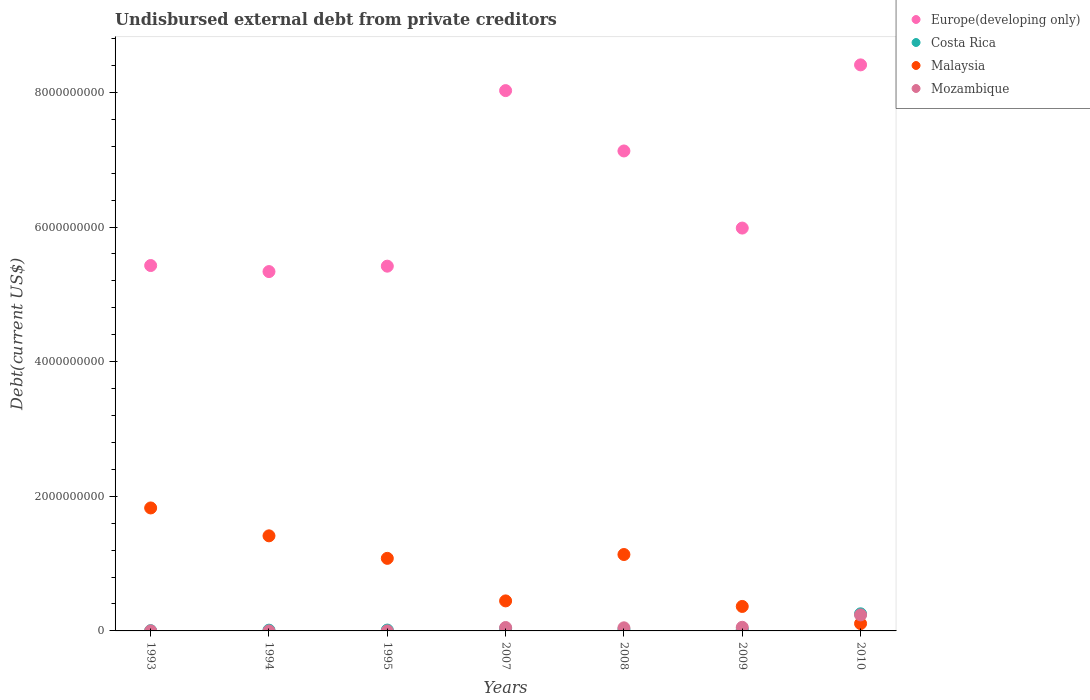How many different coloured dotlines are there?
Give a very brief answer. 4. What is the total debt in Malaysia in 1995?
Your answer should be compact. 1.08e+09. Across all years, what is the maximum total debt in Costa Rica?
Provide a short and direct response. 2.54e+08. Across all years, what is the minimum total debt in Mozambique?
Your answer should be very brief. 2.40e+04. In which year was the total debt in Costa Rica minimum?
Offer a very short reply. 1993. What is the total total debt in Costa Rica in the graph?
Your answer should be compact. 3.65e+08. What is the difference between the total debt in Costa Rica in 2007 and that in 2009?
Give a very brief answer. 1.15e+07. What is the difference between the total debt in Costa Rica in 1993 and the total debt in Malaysia in 1994?
Offer a terse response. -1.41e+09. What is the average total debt in Europe(developing only) per year?
Offer a terse response. 6.53e+09. In the year 2009, what is the difference between the total debt in Europe(developing only) and total debt in Mozambique?
Provide a succinct answer. 5.93e+09. What is the ratio of the total debt in Malaysia in 1995 to that in 2010?
Your answer should be very brief. 9.88. Is the difference between the total debt in Europe(developing only) in 2009 and 2010 greater than the difference between the total debt in Mozambique in 2009 and 2010?
Offer a very short reply. No. What is the difference between the highest and the second highest total debt in Malaysia?
Provide a succinct answer. 4.14e+08. What is the difference between the highest and the lowest total debt in Malaysia?
Ensure brevity in your answer.  1.72e+09. In how many years, is the total debt in Costa Rica greater than the average total debt in Costa Rica taken over all years?
Your answer should be very brief. 1. Is it the case that in every year, the sum of the total debt in Europe(developing only) and total debt in Costa Rica  is greater than the sum of total debt in Malaysia and total debt in Mozambique?
Make the answer very short. Yes. Is it the case that in every year, the sum of the total debt in Europe(developing only) and total debt in Malaysia  is greater than the total debt in Costa Rica?
Offer a terse response. Yes. Is the total debt in Mozambique strictly greater than the total debt in Europe(developing only) over the years?
Make the answer very short. No. How many years are there in the graph?
Provide a short and direct response. 7. What is the difference between two consecutive major ticks on the Y-axis?
Your answer should be compact. 2.00e+09. Are the values on the major ticks of Y-axis written in scientific E-notation?
Provide a succinct answer. No. Does the graph contain grids?
Keep it short and to the point. No. How many legend labels are there?
Offer a terse response. 4. What is the title of the graph?
Provide a succinct answer. Undisbursed external debt from private creditors. Does "Sudan" appear as one of the legend labels in the graph?
Offer a very short reply. No. What is the label or title of the Y-axis?
Make the answer very short. Debt(current US$). What is the Debt(current US$) in Europe(developing only) in 1993?
Provide a succinct answer. 5.43e+09. What is the Debt(current US$) of Costa Rica in 1993?
Offer a very short reply. 3.76e+06. What is the Debt(current US$) in Malaysia in 1993?
Make the answer very short. 1.83e+09. What is the Debt(current US$) of Mozambique in 1993?
Provide a succinct answer. 6.41e+05. What is the Debt(current US$) in Europe(developing only) in 1994?
Provide a short and direct response. 5.34e+09. What is the Debt(current US$) of Costa Rica in 1994?
Offer a terse response. 1.12e+07. What is the Debt(current US$) in Malaysia in 1994?
Offer a very short reply. 1.41e+09. What is the Debt(current US$) of Mozambique in 1994?
Make the answer very short. 2.40e+04. What is the Debt(current US$) of Europe(developing only) in 1995?
Your answer should be very brief. 5.42e+09. What is the Debt(current US$) in Costa Rica in 1995?
Offer a terse response. 1.28e+07. What is the Debt(current US$) in Malaysia in 1995?
Keep it short and to the point. 1.08e+09. What is the Debt(current US$) of Mozambique in 1995?
Keep it short and to the point. 2.70e+04. What is the Debt(current US$) of Europe(developing only) in 2007?
Your answer should be compact. 8.03e+09. What is the Debt(current US$) of Costa Rica in 2007?
Make the answer very short. 3.57e+07. What is the Debt(current US$) of Malaysia in 2007?
Your answer should be compact. 4.46e+08. What is the Debt(current US$) in Mozambique in 2007?
Provide a short and direct response. 5.06e+07. What is the Debt(current US$) of Europe(developing only) in 2008?
Offer a terse response. 7.13e+09. What is the Debt(current US$) of Costa Rica in 2008?
Ensure brevity in your answer.  2.34e+07. What is the Debt(current US$) in Malaysia in 2008?
Provide a succinct answer. 1.14e+09. What is the Debt(current US$) of Mozambique in 2008?
Provide a short and direct response. 4.61e+07. What is the Debt(current US$) in Europe(developing only) in 2009?
Your response must be concise. 5.98e+09. What is the Debt(current US$) of Costa Rica in 2009?
Ensure brevity in your answer.  2.42e+07. What is the Debt(current US$) of Malaysia in 2009?
Keep it short and to the point. 3.64e+08. What is the Debt(current US$) of Mozambique in 2009?
Provide a succinct answer. 5.40e+07. What is the Debt(current US$) in Europe(developing only) in 2010?
Give a very brief answer. 8.41e+09. What is the Debt(current US$) in Costa Rica in 2010?
Provide a succinct answer. 2.54e+08. What is the Debt(current US$) of Malaysia in 2010?
Offer a very short reply. 1.09e+08. What is the Debt(current US$) of Mozambique in 2010?
Keep it short and to the point. 2.38e+08. Across all years, what is the maximum Debt(current US$) in Europe(developing only)?
Keep it short and to the point. 8.41e+09. Across all years, what is the maximum Debt(current US$) of Costa Rica?
Give a very brief answer. 2.54e+08. Across all years, what is the maximum Debt(current US$) of Malaysia?
Give a very brief answer. 1.83e+09. Across all years, what is the maximum Debt(current US$) of Mozambique?
Give a very brief answer. 2.38e+08. Across all years, what is the minimum Debt(current US$) in Europe(developing only)?
Ensure brevity in your answer.  5.34e+09. Across all years, what is the minimum Debt(current US$) in Costa Rica?
Offer a very short reply. 3.76e+06. Across all years, what is the minimum Debt(current US$) of Malaysia?
Offer a very short reply. 1.09e+08. Across all years, what is the minimum Debt(current US$) of Mozambique?
Your answer should be compact. 2.40e+04. What is the total Debt(current US$) in Europe(developing only) in the graph?
Give a very brief answer. 4.57e+1. What is the total Debt(current US$) of Costa Rica in the graph?
Offer a terse response. 3.65e+08. What is the total Debt(current US$) in Malaysia in the graph?
Your answer should be compact. 6.37e+09. What is the total Debt(current US$) of Mozambique in the graph?
Ensure brevity in your answer.  3.89e+08. What is the difference between the Debt(current US$) of Europe(developing only) in 1993 and that in 1994?
Provide a short and direct response. 8.98e+07. What is the difference between the Debt(current US$) in Costa Rica in 1993 and that in 1994?
Give a very brief answer. -7.47e+06. What is the difference between the Debt(current US$) of Malaysia in 1993 and that in 1994?
Keep it short and to the point. 4.14e+08. What is the difference between the Debt(current US$) of Mozambique in 1993 and that in 1994?
Keep it short and to the point. 6.17e+05. What is the difference between the Debt(current US$) of Europe(developing only) in 1993 and that in 1995?
Make the answer very short. 9.35e+06. What is the difference between the Debt(current US$) in Costa Rica in 1993 and that in 1995?
Offer a terse response. -9.03e+06. What is the difference between the Debt(current US$) of Malaysia in 1993 and that in 1995?
Your answer should be very brief. 7.49e+08. What is the difference between the Debt(current US$) of Mozambique in 1993 and that in 1995?
Ensure brevity in your answer.  6.14e+05. What is the difference between the Debt(current US$) in Europe(developing only) in 1993 and that in 2007?
Offer a terse response. -2.60e+09. What is the difference between the Debt(current US$) of Costa Rica in 1993 and that in 2007?
Give a very brief answer. -3.20e+07. What is the difference between the Debt(current US$) in Malaysia in 1993 and that in 2007?
Ensure brevity in your answer.  1.38e+09. What is the difference between the Debt(current US$) in Mozambique in 1993 and that in 2007?
Your answer should be compact. -5.00e+07. What is the difference between the Debt(current US$) of Europe(developing only) in 1993 and that in 2008?
Offer a terse response. -1.70e+09. What is the difference between the Debt(current US$) in Costa Rica in 1993 and that in 2008?
Provide a short and direct response. -1.96e+07. What is the difference between the Debt(current US$) of Malaysia in 1993 and that in 2008?
Keep it short and to the point. 6.92e+08. What is the difference between the Debt(current US$) of Mozambique in 1993 and that in 2008?
Keep it short and to the point. -4.55e+07. What is the difference between the Debt(current US$) in Europe(developing only) in 1993 and that in 2009?
Offer a very short reply. -5.57e+08. What is the difference between the Debt(current US$) in Costa Rica in 1993 and that in 2009?
Your answer should be very brief. -2.04e+07. What is the difference between the Debt(current US$) of Malaysia in 1993 and that in 2009?
Your answer should be very brief. 1.46e+09. What is the difference between the Debt(current US$) in Mozambique in 1993 and that in 2009?
Your response must be concise. -5.33e+07. What is the difference between the Debt(current US$) in Europe(developing only) in 1993 and that in 2010?
Ensure brevity in your answer.  -2.98e+09. What is the difference between the Debt(current US$) in Costa Rica in 1993 and that in 2010?
Keep it short and to the point. -2.50e+08. What is the difference between the Debt(current US$) of Malaysia in 1993 and that in 2010?
Provide a short and direct response. 1.72e+09. What is the difference between the Debt(current US$) of Mozambique in 1993 and that in 2010?
Give a very brief answer. -2.37e+08. What is the difference between the Debt(current US$) of Europe(developing only) in 1994 and that in 1995?
Provide a short and direct response. -8.05e+07. What is the difference between the Debt(current US$) of Costa Rica in 1994 and that in 1995?
Keep it short and to the point. -1.56e+06. What is the difference between the Debt(current US$) of Malaysia in 1994 and that in 1995?
Provide a short and direct response. 3.34e+08. What is the difference between the Debt(current US$) of Mozambique in 1994 and that in 1995?
Offer a very short reply. -3000. What is the difference between the Debt(current US$) in Europe(developing only) in 1994 and that in 2007?
Offer a very short reply. -2.69e+09. What is the difference between the Debt(current US$) in Costa Rica in 1994 and that in 2007?
Your answer should be compact. -2.45e+07. What is the difference between the Debt(current US$) in Malaysia in 1994 and that in 2007?
Give a very brief answer. 9.67e+08. What is the difference between the Debt(current US$) of Mozambique in 1994 and that in 2007?
Provide a succinct answer. -5.06e+07. What is the difference between the Debt(current US$) of Europe(developing only) in 1994 and that in 2008?
Give a very brief answer. -1.79e+09. What is the difference between the Debt(current US$) of Costa Rica in 1994 and that in 2008?
Keep it short and to the point. -1.21e+07. What is the difference between the Debt(current US$) of Malaysia in 1994 and that in 2008?
Your answer should be compact. 2.77e+08. What is the difference between the Debt(current US$) of Mozambique in 1994 and that in 2008?
Provide a short and direct response. -4.61e+07. What is the difference between the Debt(current US$) of Europe(developing only) in 1994 and that in 2009?
Your response must be concise. -6.46e+08. What is the difference between the Debt(current US$) of Costa Rica in 1994 and that in 2009?
Provide a short and direct response. -1.30e+07. What is the difference between the Debt(current US$) of Malaysia in 1994 and that in 2009?
Provide a succinct answer. 1.05e+09. What is the difference between the Debt(current US$) of Mozambique in 1994 and that in 2009?
Give a very brief answer. -5.39e+07. What is the difference between the Debt(current US$) in Europe(developing only) in 1994 and that in 2010?
Keep it short and to the point. -3.07e+09. What is the difference between the Debt(current US$) in Costa Rica in 1994 and that in 2010?
Keep it short and to the point. -2.43e+08. What is the difference between the Debt(current US$) of Malaysia in 1994 and that in 2010?
Your answer should be compact. 1.30e+09. What is the difference between the Debt(current US$) of Mozambique in 1994 and that in 2010?
Provide a succinct answer. -2.38e+08. What is the difference between the Debt(current US$) of Europe(developing only) in 1995 and that in 2007?
Your response must be concise. -2.61e+09. What is the difference between the Debt(current US$) in Costa Rica in 1995 and that in 2007?
Make the answer very short. -2.29e+07. What is the difference between the Debt(current US$) in Malaysia in 1995 and that in 2007?
Your answer should be compact. 6.32e+08. What is the difference between the Debt(current US$) in Mozambique in 1995 and that in 2007?
Provide a short and direct response. -5.06e+07. What is the difference between the Debt(current US$) in Europe(developing only) in 1995 and that in 2008?
Keep it short and to the point. -1.71e+09. What is the difference between the Debt(current US$) of Costa Rica in 1995 and that in 2008?
Give a very brief answer. -1.06e+07. What is the difference between the Debt(current US$) in Malaysia in 1995 and that in 2008?
Ensure brevity in your answer.  -5.69e+07. What is the difference between the Debt(current US$) of Mozambique in 1995 and that in 2008?
Provide a short and direct response. -4.61e+07. What is the difference between the Debt(current US$) of Europe(developing only) in 1995 and that in 2009?
Give a very brief answer. -5.66e+08. What is the difference between the Debt(current US$) of Costa Rica in 1995 and that in 2009?
Your answer should be very brief. -1.14e+07. What is the difference between the Debt(current US$) of Malaysia in 1995 and that in 2009?
Provide a succinct answer. 7.14e+08. What is the difference between the Debt(current US$) in Mozambique in 1995 and that in 2009?
Provide a short and direct response. -5.39e+07. What is the difference between the Debt(current US$) of Europe(developing only) in 1995 and that in 2010?
Keep it short and to the point. -2.99e+09. What is the difference between the Debt(current US$) in Costa Rica in 1995 and that in 2010?
Your response must be concise. -2.41e+08. What is the difference between the Debt(current US$) in Malaysia in 1995 and that in 2010?
Offer a very short reply. 9.69e+08. What is the difference between the Debt(current US$) in Mozambique in 1995 and that in 2010?
Your answer should be very brief. -2.38e+08. What is the difference between the Debt(current US$) of Europe(developing only) in 2007 and that in 2008?
Your answer should be very brief. 8.97e+08. What is the difference between the Debt(current US$) of Costa Rica in 2007 and that in 2008?
Offer a terse response. 1.24e+07. What is the difference between the Debt(current US$) of Malaysia in 2007 and that in 2008?
Keep it short and to the point. -6.89e+08. What is the difference between the Debt(current US$) in Mozambique in 2007 and that in 2008?
Provide a short and direct response. 4.54e+06. What is the difference between the Debt(current US$) of Europe(developing only) in 2007 and that in 2009?
Your response must be concise. 2.04e+09. What is the difference between the Debt(current US$) in Costa Rica in 2007 and that in 2009?
Your response must be concise. 1.15e+07. What is the difference between the Debt(current US$) of Malaysia in 2007 and that in 2009?
Offer a very short reply. 8.24e+07. What is the difference between the Debt(current US$) in Mozambique in 2007 and that in 2009?
Your answer should be very brief. -3.32e+06. What is the difference between the Debt(current US$) of Europe(developing only) in 2007 and that in 2010?
Provide a short and direct response. -3.82e+08. What is the difference between the Debt(current US$) in Costa Rica in 2007 and that in 2010?
Give a very brief answer. -2.18e+08. What is the difference between the Debt(current US$) of Malaysia in 2007 and that in 2010?
Your response must be concise. 3.37e+08. What is the difference between the Debt(current US$) in Mozambique in 2007 and that in 2010?
Keep it short and to the point. -1.87e+08. What is the difference between the Debt(current US$) of Europe(developing only) in 2008 and that in 2009?
Your response must be concise. 1.15e+09. What is the difference between the Debt(current US$) in Costa Rica in 2008 and that in 2009?
Offer a very short reply. -8.21e+05. What is the difference between the Debt(current US$) in Malaysia in 2008 and that in 2009?
Your response must be concise. 7.71e+08. What is the difference between the Debt(current US$) in Mozambique in 2008 and that in 2009?
Provide a short and direct response. -7.85e+06. What is the difference between the Debt(current US$) of Europe(developing only) in 2008 and that in 2010?
Provide a short and direct response. -1.28e+09. What is the difference between the Debt(current US$) in Costa Rica in 2008 and that in 2010?
Your answer should be compact. -2.31e+08. What is the difference between the Debt(current US$) in Malaysia in 2008 and that in 2010?
Keep it short and to the point. 1.03e+09. What is the difference between the Debt(current US$) in Mozambique in 2008 and that in 2010?
Offer a very short reply. -1.92e+08. What is the difference between the Debt(current US$) of Europe(developing only) in 2009 and that in 2010?
Offer a very short reply. -2.42e+09. What is the difference between the Debt(current US$) in Costa Rica in 2009 and that in 2010?
Ensure brevity in your answer.  -2.30e+08. What is the difference between the Debt(current US$) in Malaysia in 2009 and that in 2010?
Make the answer very short. 2.55e+08. What is the difference between the Debt(current US$) of Mozambique in 2009 and that in 2010?
Keep it short and to the point. -1.84e+08. What is the difference between the Debt(current US$) of Europe(developing only) in 1993 and the Debt(current US$) of Costa Rica in 1994?
Your answer should be very brief. 5.42e+09. What is the difference between the Debt(current US$) in Europe(developing only) in 1993 and the Debt(current US$) in Malaysia in 1994?
Your answer should be compact. 4.02e+09. What is the difference between the Debt(current US$) of Europe(developing only) in 1993 and the Debt(current US$) of Mozambique in 1994?
Make the answer very short. 5.43e+09. What is the difference between the Debt(current US$) in Costa Rica in 1993 and the Debt(current US$) in Malaysia in 1994?
Offer a very short reply. -1.41e+09. What is the difference between the Debt(current US$) in Costa Rica in 1993 and the Debt(current US$) in Mozambique in 1994?
Make the answer very short. 3.74e+06. What is the difference between the Debt(current US$) in Malaysia in 1993 and the Debt(current US$) in Mozambique in 1994?
Ensure brevity in your answer.  1.83e+09. What is the difference between the Debt(current US$) of Europe(developing only) in 1993 and the Debt(current US$) of Costa Rica in 1995?
Your answer should be compact. 5.42e+09. What is the difference between the Debt(current US$) of Europe(developing only) in 1993 and the Debt(current US$) of Malaysia in 1995?
Your response must be concise. 4.35e+09. What is the difference between the Debt(current US$) of Europe(developing only) in 1993 and the Debt(current US$) of Mozambique in 1995?
Your answer should be very brief. 5.43e+09. What is the difference between the Debt(current US$) of Costa Rica in 1993 and the Debt(current US$) of Malaysia in 1995?
Ensure brevity in your answer.  -1.07e+09. What is the difference between the Debt(current US$) in Costa Rica in 1993 and the Debt(current US$) in Mozambique in 1995?
Your response must be concise. 3.73e+06. What is the difference between the Debt(current US$) of Malaysia in 1993 and the Debt(current US$) of Mozambique in 1995?
Offer a terse response. 1.83e+09. What is the difference between the Debt(current US$) of Europe(developing only) in 1993 and the Debt(current US$) of Costa Rica in 2007?
Your answer should be very brief. 5.39e+09. What is the difference between the Debt(current US$) of Europe(developing only) in 1993 and the Debt(current US$) of Malaysia in 2007?
Your answer should be compact. 4.98e+09. What is the difference between the Debt(current US$) of Europe(developing only) in 1993 and the Debt(current US$) of Mozambique in 2007?
Offer a terse response. 5.38e+09. What is the difference between the Debt(current US$) of Costa Rica in 1993 and the Debt(current US$) of Malaysia in 2007?
Provide a succinct answer. -4.42e+08. What is the difference between the Debt(current US$) of Costa Rica in 1993 and the Debt(current US$) of Mozambique in 2007?
Provide a short and direct response. -4.69e+07. What is the difference between the Debt(current US$) of Malaysia in 1993 and the Debt(current US$) of Mozambique in 2007?
Provide a short and direct response. 1.78e+09. What is the difference between the Debt(current US$) of Europe(developing only) in 1993 and the Debt(current US$) of Costa Rica in 2008?
Your answer should be very brief. 5.40e+09. What is the difference between the Debt(current US$) of Europe(developing only) in 1993 and the Debt(current US$) of Malaysia in 2008?
Keep it short and to the point. 4.29e+09. What is the difference between the Debt(current US$) of Europe(developing only) in 1993 and the Debt(current US$) of Mozambique in 2008?
Ensure brevity in your answer.  5.38e+09. What is the difference between the Debt(current US$) of Costa Rica in 1993 and the Debt(current US$) of Malaysia in 2008?
Give a very brief answer. -1.13e+09. What is the difference between the Debt(current US$) in Costa Rica in 1993 and the Debt(current US$) in Mozambique in 2008?
Offer a very short reply. -4.24e+07. What is the difference between the Debt(current US$) of Malaysia in 1993 and the Debt(current US$) of Mozambique in 2008?
Offer a very short reply. 1.78e+09. What is the difference between the Debt(current US$) in Europe(developing only) in 1993 and the Debt(current US$) in Costa Rica in 2009?
Offer a terse response. 5.40e+09. What is the difference between the Debt(current US$) in Europe(developing only) in 1993 and the Debt(current US$) in Malaysia in 2009?
Ensure brevity in your answer.  5.06e+09. What is the difference between the Debt(current US$) in Europe(developing only) in 1993 and the Debt(current US$) in Mozambique in 2009?
Make the answer very short. 5.37e+09. What is the difference between the Debt(current US$) in Costa Rica in 1993 and the Debt(current US$) in Malaysia in 2009?
Provide a short and direct response. -3.60e+08. What is the difference between the Debt(current US$) of Costa Rica in 1993 and the Debt(current US$) of Mozambique in 2009?
Give a very brief answer. -5.02e+07. What is the difference between the Debt(current US$) of Malaysia in 1993 and the Debt(current US$) of Mozambique in 2009?
Your answer should be very brief. 1.77e+09. What is the difference between the Debt(current US$) of Europe(developing only) in 1993 and the Debt(current US$) of Costa Rica in 2010?
Provide a short and direct response. 5.17e+09. What is the difference between the Debt(current US$) in Europe(developing only) in 1993 and the Debt(current US$) in Malaysia in 2010?
Your answer should be compact. 5.32e+09. What is the difference between the Debt(current US$) of Europe(developing only) in 1993 and the Debt(current US$) of Mozambique in 2010?
Your answer should be very brief. 5.19e+09. What is the difference between the Debt(current US$) of Costa Rica in 1993 and the Debt(current US$) of Malaysia in 2010?
Your answer should be compact. -1.05e+08. What is the difference between the Debt(current US$) of Costa Rica in 1993 and the Debt(current US$) of Mozambique in 2010?
Give a very brief answer. -2.34e+08. What is the difference between the Debt(current US$) in Malaysia in 1993 and the Debt(current US$) in Mozambique in 2010?
Your response must be concise. 1.59e+09. What is the difference between the Debt(current US$) in Europe(developing only) in 1994 and the Debt(current US$) in Costa Rica in 1995?
Provide a succinct answer. 5.33e+09. What is the difference between the Debt(current US$) of Europe(developing only) in 1994 and the Debt(current US$) of Malaysia in 1995?
Provide a short and direct response. 4.26e+09. What is the difference between the Debt(current US$) of Europe(developing only) in 1994 and the Debt(current US$) of Mozambique in 1995?
Provide a short and direct response. 5.34e+09. What is the difference between the Debt(current US$) of Costa Rica in 1994 and the Debt(current US$) of Malaysia in 1995?
Give a very brief answer. -1.07e+09. What is the difference between the Debt(current US$) of Costa Rica in 1994 and the Debt(current US$) of Mozambique in 1995?
Offer a terse response. 1.12e+07. What is the difference between the Debt(current US$) in Malaysia in 1994 and the Debt(current US$) in Mozambique in 1995?
Offer a very short reply. 1.41e+09. What is the difference between the Debt(current US$) in Europe(developing only) in 1994 and the Debt(current US$) in Costa Rica in 2007?
Offer a very short reply. 5.30e+09. What is the difference between the Debt(current US$) in Europe(developing only) in 1994 and the Debt(current US$) in Malaysia in 2007?
Ensure brevity in your answer.  4.89e+09. What is the difference between the Debt(current US$) in Europe(developing only) in 1994 and the Debt(current US$) in Mozambique in 2007?
Provide a short and direct response. 5.29e+09. What is the difference between the Debt(current US$) in Costa Rica in 1994 and the Debt(current US$) in Malaysia in 2007?
Provide a succinct answer. -4.35e+08. What is the difference between the Debt(current US$) in Costa Rica in 1994 and the Debt(current US$) in Mozambique in 2007?
Make the answer very short. -3.94e+07. What is the difference between the Debt(current US$) of Malaysia in 1994 and the Debt(current US$) of Mozambique in 2007?
Provide a succinct answer. 1.36e+09. What is the difference between the Debt(current US$) in Europe(developing only) in 1994 and the Debt(current US$) in Costa Rica in 2008?
Offer a very short reply. 5.31e+09. What is the difference between the Debt(current US$) of Europe(developing only) in 1994 and the Debt(current US$) of Malaysia in 2008?
Make the answer very short. 4.20e+09. What is the difference between the Debt(current US$) of Europe(developing only) in 1994 and the Debt(current US$) of Mozambique in 2008?
Your response must be concise. 5.29e+09. What is the difference between the Debt(current US$) in Costa Rica in 1994 and the Debt(current US$) in Malaysia in 2008?
Make the answer very short. -1.12e+09. What is the difference between the Debt(current US$) in Costa Rica in 1994 and the Debt(current US$) in Mozambique in 2008?
Offer a very short reply. -3.49e+07. What is the difference between the Debt(current US$) in Malaysia in 1994 and the Debt(current US$) in Mozambique in 2008?
Your response must be concise. 1.37e+09. What is the difference between the Debt(current US$) in Europe(developing only) in 1994 and the Debt(current US$) in Costa Rica in 2009?
Keep it short and to the point. 5.31e+09. What is the difference between the Debt(current US$) of Europe(developing only) in 1994 and the Debt(current US$) of Malaysia in 2009?
Provide a short and direct response. 4.97e+09. What is the difference between the Debt(current US$) of Europe(developing only) in 1994 and the Debt(current US$) of Mozambique in 2009?
Make the answer very short. 5.28e+09. What is the difference between the Debt(current US$) in Costa Rica in 1994 and the Debt(current US$) in Malaysia in 2009?
Your response must be concise. -3.52e+08. What is the difference between the Debt(current US$) in Costa Rica in 1994 and the Debt(current US$) in Mozambique in 2009?
Your answer should be compact. -4.27e+07. What is the difference between the Debt(current US$) in Malaysia in 1994 and the Debt(current US$) in Mozambique in 2009?
Provide a succinct answer. 1.36e+09. What is the difference between the Debt(current US$) of Europe(developing only) in 1994 and the Debt(current US$) of Costa Rica in 2010?
Offer a terse response. 5.08e+09. What is the difference between the Debt(current US$) of Europe(developing only) in 1994 and the Debt(current US$) of Malaysia in 2010?
Your response must be concise. 5.23e+09. What is the difference between the Debt(current US$) of Europe(developing only) in 1994 and the Debt(current US$) of Mozambique in 2010?
Give a very brief answer. 5.10e+09. What is the difference between the Debt(current US$) in Costa Rica in 1994 and the Debt(current US$) in Malaysia in 2010?
Give a very brief answer. -9.79e+07. What is the difference between the Debt(current US$) of Costa Rica in 1994 and the Debt(current US$) of Mozambique in 2010?
Provide a succinct answer. -2.27e+08. What is the difference between the Debt(current US$) of Malaysia in 1994 and the Debt(current US$) of Mozambique in 2010?
Your response must be concise. 1.17e+09. What is the difference between the Debt(current US$) of Europe(developing only) in 1995 and the Debt(current US$) of Costa Rica in 2007?
Provide a short and direct response. 5.38e+09. What is the difference between the Debt(current US$) in Europe(developing only) in 1995 and the Debt(current US$) in Malaysia in 2007?
Your answer should be very brief. 4.97e+09. What is the difference between the Debt(current US$) in Europe(developing only) in 1995 and the Debt(current US$) in Mozambique in 2007?
Offer a very short reply. 5.37e+09. What is the difference between the Debt(current US$) in Costa Rica in 1995 and the Debt(current US$) in Malaysia in 2007?
Ensure brevity in your answer.  -4.33e+08. What is the difference between the Debt(current US$) in Costa Rica in 1995 and the Debt(current US$) in Mozambique in 2007?
Your response must be concise. -3.79e+07. What is the difference between the Debt(current US$) in Malaysia in 1995 and the Debt(current US$) in Mozambique in 2007?
Your answer should be very brief. 1.03e+09. What is the difference between the Debt(current US$) of Europe(developing only) in 1995 and the Debt(current US$) of Costa Rica in 2008?
Your response must be concise. 5.40e+09. What is the difference between the Debt(current US$) in Europe(developing only) in 1995 and the Debt(current US$) in Malaysia in 2008?
Provide a short and direct response. 4.28e+09. What is the difference between the Debt(current US$) in Europe(developing only) in 1995 and the Debt(current US$) in Mozambique in 2008?
Give a very brief answer. 5.37e+09. What is the difference between the Debt(current US$) of Costa Rica in 1995 and the Debt(current US$) of Malaysia in 2008?
Offer a terse response. -1.12e+09. What is the difference between the Debt(current US$) of Costa Rica in 1995 and the Debt(current US$) of Mozambique in 2008?
Provide a succinct answer. -3.33e+07. What is the difference between the Debt(current US$) of Malaysia in 1995 and the Debt(current US$) of Mozambique in 2008?
Ensure brevity in your answer.  1.03e+09. What is the difference between the Debt(current US$) in Europe(developing only) in 1995 and the Debt(current US$) in Costa Rica in 2009?
Provide a succinct answer. 5.39e+09. What is the difference between the Debt(current US$) in Europe(developing only) in 1995 and the Debt(current US$) in Malaysia in 2009?
Ensure brevity in your answer.  5.06e+09. What is the difference between the Debt(current US$) of Europe(developing only) in 1995 and the Debt(current US$) of Mozambique in 2009?
Offer a terse response. 5.36e+09. What is the difference between the Debt(current US$) in Costa Rica in 1995 and the Debt(current US$) in Malaysia in 2009?
Provide a succinct answer. -3.51e+08. What is the difference between the Debt(current US$) in Costa Rica in 1995 and the Debt(current US$) in Mozambique in 2009?
Ensure brevity in your answer.  -4.12e+07. What is the difference between the Debt(current US$) of Malaysia in 1995 and the Debt(current US$) of Mozambique in 2009?
Make the answer very short. 1.02e+09. What is the difference between the Debt(current US$) in Europe(developing only) in 1995 and the Debt(current US$) in Costa Rica in 2010?
Offer a very short reply. 5.16e+09. What is the difference between the Debt(current US$) of Europe(developing only) in 1995 and the Debt(current US$) of Malaysia in 2010?
Keep it short and to the point. 5.31e+09. What is the difference between the Debt(current US$) of Europe(developing only) in 1995 and the Debt(current US$) of Mozambique in 2010?
Keep it short and to the point. 5.18e+09. What is the difference between the Debt(current US$) in Costa Rica in 1995 and the Debt(current US$) in Malaysia in 2010?
Provide a succinct answer. -9.63e+07. What is the difference between the Debt(current US$) of Costa Rica in 1995 and the Debt(current US$) of Mozambique in 2010?
Provide a succinct answer. -2.25e+08. What is the difference between the Debt(current US$) of Malaysia in 1995 and the Debt(current US$) of Mozambique in 2010?
Provide a short and direct response. 8.40e+08. What is the difference between the Debt(current US$) in Europe(developing only) in 2007 and the Debt(current US$) in Costa Rica in 2008?
Ensure brevity in your answer.  8.00e+09. What is the difference between the Debt(current US$) in Europe(developing only) in 2007 and the Debt(current US$) in Malaysia in 2008?
Ensure brevity in your answer.  6.89e+09. What is the difference between the Debt(current US$) of Europe(developing only) in 2007 and the Debt(current US$) of Mozambique in 2008?
Give a very brief answer. 7.98e+09. What is the difference between the Debt(current US$) in Costa Rica in 2007 and the Debt(current US$) in Malaysia in 2008?
Keep it short and to the point. -1.10e+09. What is the difference between the Debt(current US$) of Costa Rica in 2007 and the Debt(current US$) of Mozambique in 2008?
Keep it short and to the point. -1.04e+07. What is the difference between the Debt(current US$) of Malaysia in 2007 and the Debt(current US$) of Mozambique in 2008?
Keep it short and to the point. 4.00e+08. What is the difference between the Debt(current US$) of Europe(developing only) in 2007 and the Debt(current US$) of Costa Rica in 2009?
Your answer should be very brief. 8.00e+09. What is the difference between the Debt(current US$) in Europe(developing only) in 2007 and the Debt(current US$) in Malaysia in 2009?
Your answer should be compact. 7.66e+09. What is the difference between the Debt(current US$) in Europe(developing only) in 2007 and the Debt(current US$) in Mozambique in 2009?
Provide a short and direct response. 7.97e+09. What is the difference between the Debt(current US$) of Costa Rica in 2007 and the Debt(current US$) of Malaysia in 2009?
Provide a short and direct response. -3.28e+08. What is the difference between the Debt(current US$) of Costa Rica in 2007 and the Debt(current US$) of Mozambique in 2009?
Offer a terse response. -1.82e+07. What is the difference between the Debt(current US$) in Malaysia in 2007 and the Debt(current US$) in Mozambique in 2009?
Your answer should be compact. 3.92e+08. What is the difference between the Debt(current US$) in Europe(developing only) in 2007 and the Debt(current US$) in Costa Rica in 2010?
Your answer should be very brief. 7.77e+09. What is the difference between the Debt(current US$) in Europe(developing only) in 2007 and the Debt(current US$) in Malaysia in 2010?
Make the answer very short. 7.92e+09. What is the difference between the Debt(current US$) in Europe(developing only) in 2007 and the Debt(current US$) in Mozambique in 2010?
Your answer should be very brief. 7.79e+09. What is the difference between the Debt(current US$) of Costa Rica in 2007 and the Debt(current US$) of Malaysia in 2010?
Your answer should be compact. -7.34e+07. What is the difference between the Debt(current US$) in Costa Rica in 2007 and the Debt(current US$) in Mozambique in 2010?
Offer a terse response. -2.02e+08. What is the difference between the Debt(current US$) of Malaysia in 2007 and the Debt(current US$) of Mozambique in 2010?
Offer a very short reply. 2.08e+08. What is the difference between the Debt(current US$) in Europe(developing only) in 2008 and the Debt(current US$) in Costa Rica in 2009?
Keep it short and to the point. 7.11e+09. What is the difference between the Debt(current US$) of Europe(developing only) in 2008 and the Debt(current US$) of Malaysia in 2009?
Ensure brevity in your answer.  6.77e+09. What is the difference between the Debt(current US$) in Europe(developing only) in 2008 and the Debt(current US$) in Mozambique in 2009?
Provide a short and direct response. 7.08e+09. What is the difference between the Debt(current US$) of Costa Rica in 2008 and the Debt(current US$) of Malaysia in 2009?
Your answer should be compact. -3.40e+08. What is the difference between the Debt(current US$) of Costa Rica in 2008 and the Debt(current US$) of Mozambique in 2009?
Your answer should be very brief. -3.06e+07. What is the difference between the Debt(current US$) in Malaysia in 2008 and the Debt(current US$) in Mozambique in 2009?
Give a very brief answer. 1.08e+09. What is the difference between the Debt(current US$) of Europe(developing only) in 2008 and the Debt(current US$) of Costa Rica in 2010?
Your answer should be very brief. 6.88e+09. What is the difference between the Debt(current US$) of Europe(developing only) in 2008 and the Debt(current US$) of Malaysia in 2010?
Offer a very short reply. 7.02e+09. What is the difference between the Debt(current US$) in Europe(developing only) in 2008 and the Debt(current US$) in Mozambique in 2010?
Offer a terse response. 6.89e+09. What is the difference between the Debt(current US$) of Costa Rica in 2008 and the Debt(current US$) of Malaysia in 2010?
Provide a short and direct response. -8.57e+07. What is the difference between the Debt(current US$) of Costa Rica in 2008 and the Debt(current US$) of Mozambique in 2010?
Give a very brief answer. -2.14e+08. What is the difference between the Debt(current US$) in Malaysia in 2008 and the Debt(current US$) in Mozambique in 2010?
Keep it short and to the point. 8.97e+08. What is the difference between the Debt(current US$) of Europe(developing only) in 2009 and the Debt(current US$) of Costa Rica in 2010?
Ensure brevity in your answer.  5.73e+09. What is the difference between the Debt(current US$) of Europe(developing only) in 2009 and the Debt(current US$) of Malaysia in 2010?
Provide a succinct answer. 5.88e+09. What is the difference between the Debt(current US$) of Europe(developing only) in 2009 and the Debt(current US$) of Mozambique in 2010?
Your answer should be very brief. 5.75e+09. What is the difference between the Debt(current US$) of Costa Rica in 2009 and the Debt(current US$) of Malaysia in 2010?
Offer a terse response. -8.49e+07. What is the difference between the Debt(current US$) in Costa Rica in 2009 and the Debt(current US$) in Mozambique in 2010?
Make the answer very short. -2.14e+08. What is the difference between the Debt(current US$) in Malaysia in 2009 and the Debt(current US$) in Mozambique in 2010?
Your response must be concise. 1.26e+08. What is the average Debt(current US$) in Europe(developing only) per year?
Give a very brief answer. 6.53e+09. What is the average Debt(current US$) in Costa Rica per year?
Give a very brief answer. 5.22e+07. What is the average Debt(current US$) in Malaysia per year?
Provide a succinct answer. 9.10e+08. What is the average Debt(current US$) of Mozambique per year?
Offer a terse response. 5.56e+07. In the year 1993, what is the difference between the Debt(current US$) in Europe(developing only) and Debt(current US$) in Costa Rica?
Offer a very short reply. 5.42e+09. In the year 1993, what is the difference between the Debt(current US$) of Europe(developing only) and Debt(current US$) of Malaysia?
Offer a very short reply. 3.60e+09. In the year 1993, what is the difference between the Debt(current US$) in Europe(developing only) and Debt(current US$) in Mozambique?
Offer a very short reply. 5.43e+09. In the year 1993, what is the difference between the Debt(current US$) of Costa Rica and Debt(current US$) of Malaysia?
Provide a short and direct response. -1.82e+09. In the year 1993, what is the difference between the Debt(current US$) in Costa Rica and Debt(current US$) in Mozambique?
Your response must be concise. 3.12e+06. In the year 1993, what is the difference between the Debt(current US$) in Malaysia and Debt(current US$) in Mozambique?
Provide a succinct answer. 1.83e+09. In the year 1994, what is the difference between the Debt(current US$) in Europe(developing only) and Debt(current US$) in Costa Rica?
Offer a very short reply. 5.33e+09. In the year 1994, what is the difference between the Debt(current US$) in Europe(developing only) and Debt(current US$) in Malaysia?
Give a very brief answer. 3.93e+09. In the year 1994, what is the difference between the Debt(current US$) in Europe(developing only) and Debt(current US$) in Mozambique?
Provide a succinct answer. 5.34e+09. In the year 1994, what is the difference between the Debt(current US$) of Costa Rica and Debt(current US$) of Malaysia?
Give a very brief answer. -1.40e+09. In the year 1994, what is the difference between the Debt(current US$) in Costa Rica and Debt(current US$) in Mozambique?
Provide a short and direct response. 1.12e+07. In the year 1994, what is the difference between the Debt(current US$) in Malaysia and Debt(current US$) in Mozambique?
Your response must be concise. 1.41e+09. In the year 1995, what is the difference between the Debt(current US$) of Europe(developing only) and Debt(current US$) of Costa Rica?
Give a very brief answer. 5.41e+09. In the year 1995, what is the difference between the Debt(current US$) of Europe(developing only) and Debt(current US$) of Malaysia?
Make the answer very short. 4.34e+09. In the year 1995, what is the difference between the Debt(current US$) in Europe(developing only) and Debt(current US$) in Mozambique?
Provide a succinct answer. 5.42e+09. In the year 1995, what is the difference between the Debt(current US$) in Costa Rica and Debt(current US$) in Malaysia?
Offer a terse response. -1.07e+09. In the year 1995, what is the difference between the Debt(current US$) in Costa Rica and Debt(current US$) in Mozambique?
Provide a short and direct response. 1.28e+07. In the year 1995, what is the difference between the Debt(current US$) of Malaysia and Debt(current US$) of Mozambique?
Offer a very short reply. 1.08e+09. In the year 2007, what is the difference between the Debt(current US$) of Europe(developing only) and Debt(current US$) of Costa Rica?
Provide a succinct answer. 7.99e+09. In the year 2007, what is the difference between the Debt(current US$) in Europe(developing only) and Debt(current US$) in Malaysia?
Your answer should be compact. 7.58e+09. In the year 2007, what is the difference between the Debt(current US$) in Europe(developing only) and Debt(current US$) in Mozambique?
Offer a terse response. 7.98e+09. In the year 2007, what is the difference between the Debt(current US$) of Costa Rica and Debt(current US$) of Malaysia?
Provide a short and direct response. -4.10e+08. In the year 2007, what is the difference between the Debt(current US$) of Costa Rica and Debt(current US$) of Mozambique?
Your response must be concise. -1.49e+07. In the year 2007, what is the difference between the Debt(current US$) in Malaysia and Debt(current US$) in Mozambique?
Your response must be concise. 3.95e+08. In the year 2008, what is the difference between the Debt(current US$) in Europe(developing only) and Debt(current US$) in Costa Rica?
Provide a short and direct response. 7.11e+09. In the year 2008, what is the difference between the Debt(current US$) of Europe(developing only) and Debt(current US$) of Malaysia?
Provide a short and direct response. 6.00e+09. In the year 2008, what is the difference between the Debt(current US$) in Europe(developing only) and Debt(current US$) in Mozambique?
Your answer should be compact. 7.08e+09. In the year 2008, what is the difference between the Debt(current US$) of Costa Rica and Debt(current US$) of Malaysia?
Provide a short and direct response. -1.11e+09. In the year 2008, what is the difference between the Debt(current US$) in Costa Rica and Debt(current US$) in Mozambique?
Provide a short and direct response. -2.27e+07. In the year 2008, what is the difference between the Debt(current US$) in Malaysia and Debt(current US$) in Mozambique?
Make the answer very short. 1.09e+09. In the year 2009, what is the difference between the Debt(current US$) in Europe(developing only) and Debt(current US$) in Costa Rica?
Your answer should be very brief. 5.96e+09. In the year 2009, what is the difference between the Debt(current US$) of Europe(developing only) and Debt(current US$) of Malaysia?
Your answer should be very brief. 5.62e+09. In the year 2009, what is the difference between the Debt(current US$) of Europe(developing only) and Debt(current US$) of Mozambique?
Ensure brevity in your answer.  5.93e+09. In the year 2009, what is the difference between the Debt(current US$) in Costa Rica and Debt(current US$) in Malaysia?
Keep it short and to the point. -3.39e+08. In the year 2009, what is the difference between the Debt(current US$) of Costa Rica and Debt(current US$) of Mozambique?
Your response must be concise. -2.98e+07. In the year 2009, what is the difference between the Debt(current US$) of Malaysia and Debt(current US$) of Mozambique?
Offer a terse response. 3.10e+08. In the year 2010, what is the difference between the Debt(current US$) in Europe(developing only) and Debt(current US$) in Costa Rica?
Provide a short and direct response. 8.16e+09. In the year 2010, what is the difference between the Debt(current US$) in Europe(developing only) and Debt(current US$) in Malaysia?
Give a very brief answer. 8.30e+09. In the year 2010, what is the difference between the Debt(current US$) of Europe(developing only) and Debt(current US$) of Mozambique?
Offer a very short reply. 8.17e+09. In the year 2010, what is the difference between the Debt(current US$) in Costa Rica and Debt(current US$) in Malaysia?
Provide a short and direct response. 1.45e+08. In the year 2010, what is the difference between the Debt(current US$) in Costa Rica and Debt(current US$) in Mozambique?
Your answer should be compact. 1.62e+07. In the year 2010, what is the difference between the Debt(current US$) in Malaysia and Debt(current US$) in Mozambique?
Provide a short and direct response. -1.29e+08. What is the ratio of the Debt(current US$) of Europe(developing only) in 1993 to that in 1994?
Offer a very short reply. 1.02. What is the ratio of the Debt(current US$) of Costa Rica in 1993 to that in 1994?
Keep it short and to the point. 0.33. What is the ratio of the Debt(current US$) in Malaysia in 1993 to that in 1994?
Give a very brief answer. 1.29. What is the ratio of the Debt(current US$) in Mozambique in 1993 to that in 1994?
Your answer should be very brief. 26.71. What is the ratio of the Debt(current US$) in Europe(developing only) in 1993 to that in 1995?
Provide a succinct answer. 1. What is the ratio of the Debt(current US$) in Costa Rica in 1993 to that in 1995?
Give a very brief answer. 0.29. What is the ratio of the Debt(current US$) in Malaysia in 1993 to that in 1995?
Ensure brevity in your answer.  1.69. What is the ratio of the Debt(current US$) in Mozambique in 1993 to that in 1995?
Your answer should be very brief. 23.74. What is the ratio of the Debt(current US$) of Europe(developing only) in 1993 to that in 2007?
Offer a very short reply. 0.68. What is the ratio of the Debt(current US$) of Costa Rica in 1993 to that in 2007?
Give a very brief answer. 0.11. What is the ratio of the Debt(current US$) of Malaysia in 1993 to that in 2007?
Give a very brief answer. 4.1. What is the ratio of the Debt(current US$) in Mozambique in 1993 to that in 2007?
Give a very brief answer. 0.01. What is the ratio of the Debt(current US$) in Europe(developing only) in 1993 to that in 2008?
Offer a very short reply. 0.76. What is the ratio of the Debt(current US$) in Costa Rica in 1993 to that in 2008?
Your response must be concise. 0.16. What is the ratio of the Debt(current US$) in Malaysia in 1993 to that in 2008?
Offer a very short reply. 1.61. What is the ratio of the Debt(current US$) of Mozambique in 1993 to that in 2008?
Provide a succinct answer. 0.01. What is the ratio of the Debt(current US$) of Europe(developing only) in 1993 to that in 2009?
Offer a terse response. 0.91. What is the ratio of the Debt(current US$) of Costa Rica in 1993 to that in 2009?
Your answer should be compact. 0.16. What is the ratio of the Debt(current US$) in Malaysia in 1993 to that in 2009?
Ensure brevity in your answer.  5.02. What is the ratio of the Debt(current US$) in Mozambique in 1993 to that in 2009?
Provide a short and direct response. 0.01. What is the ratio of the Debt(current US$) of Europe(developing only) in 1993 to that in 2010?
Offer a very short reply. 0.65. What is the ratio of the Debt(current US$) in Costa Rica in 1993 to that in 2010?
Keep it short and to the point. 0.01. What is the ratio of the Debt(current US$) of Malaysia in 1993 to that in 2010?
Give a very brief answer. 16.75. What is the ratio of the Debt(current US$) in Mozambique in 1993 to that in 2010?
Provide a short and direct response. 0. What is the ratio of the Debt(current US$) of Europe(developing only) in 1994 to that in 1995?
Provide a short and direct response. 0.99. What is the ratio of the Debt(current US$) of Costa Rica in 1994 to that in 1995?
Offer a very short reply. 0.88. What is the ratio of the Debt(current US$) in Malaysia in 1994 to that in 1995?
Keep it short and to the point. 1.31. What is the ratio of the Debt(current US$) of Europe(developing only) in 1994 to that in 2007?
Provide a short and direct response. 0.67. What is the ratio of the Debt(current US$) of Costa Rica in 1994 to that in 2007?
Offer a terse response. 0.31. What is the ratio of the Debt(current US$) in Malaysia in 1994 to that in 2007?
Offer a very short reply. 3.17. What is the ratio of the Debt(current US$) in Mozambique in 1994 to that in 2007?
Provide a short and direct response. 0. What is the ratio of the Debt(current US$) of Europe(developing only) in 1994 to that in 2008?
Offer a terse response. 0.75. What is the ratio of the Debt(current US$) of Costa Rica in 1994 to that in 2008?
Provide a succinct answer. 0.48. What is the ratio of the Debt(current US$) of Malaysia in 1994 to that in 2008?
Your answer should be compact. 1.24. What is the ratio of the Debt(current US$) of Europe(developing only) in 1994 to that in 2009?
Offer a terse response. 0.89. What is the ratio of the Debt(current US$) in Costa Rica in 1994 to that in 2009?
Provide a succinct answer. 0.46. What is the ratio of the Debt(current US$) of Malaysia in 1994 to that in 2009?
Offer a very short reply. 3.88. What is the ratio of the Debt(current US$) of Mozambique in 1994 to that in 2009?
Provide a succinct answer. 0. What is the ratio of the Debt(current US$) in Europe(developing only) in 1994 to that in 2010?
Provide a succinct answer. 0.63. What is the ratio of the Debt(current US$) of Costa Rica in 1994 to that in 2010?
Ensure brevity in your answer.  0.04. What is the ratio of the Debt(current US$) in Malaysia in 1994 to that in 2010?
Keep it short and to the point. 12.95. What is the ratio of the Debt(current US$) of Europe(developing only) in 1995 to that in 2007?
Provide a short and direct response. 0.68. What is the ratio of the Debt(current US$) of Costa Rica in 1995 to that in 2007?
Provide a succinct answer. 0.36. What is the ratio of the Debt(current US$) in Malaysia in 1995 to that in 2007?
Offer a very short reply. 2.42. What is the ratio of the Debt(current US$) in Europe(developing only) in 1995 to that in 2008?
Your response must be concise. 0.76. What is the ratio of the Debt(current US$) of Costa Rica in 1995 to that in 2008?
Your answer should be compact. 0.55. What is the ratio of the Debt(current US$) in Malaysia in 1995 to that in 2008?
Give a very brief answer. 0.95. What is the ratio of the Debt(current US$) of Mozambique in 1995 to that in 2008?
Your response must be concise. 0. What is the ratio of the Debt(current US$) of Europe(developing only) in 1995 to that in 2009?
Your answer should be very brief. 0.91. What is the ratio of the Debt(current US$) of Costa Rica in 1995 to that in 2009?
Provide a succinct answer. 0.53. What is the ratio of the Debt(current US$) in Malaysia in 1995 to that in 2009?
Give a very brief answer. 2.96. What is the ratio of the Debt(current US$) of Mozambique in 1995 to that in 2009?
Give a very brief answer. 0. What is the ratio of the Debt(current US$) in Europe(developing only) in 1995 to that in 2010?
Offer a very short reply. 0.64. What is the ratio of the Debt(current US$) in Costa Rica in 1995 to that in 2010?
Keep it short and to the point. 0.05. What is the ratio of the Debt(current US$) of Malaysia in 1995 to that in 2010?
Offer a very short reply. 9.88. What is the ratio of the Debt(current US$) of Mozambique in 1995 to that in 2010?
Offer a very short reply. 0. What is the ratio of the Debt(current US$) of Europe(developing only) in 2007 to that in 2008?
Your answer should be very brief. 1.13. What is the ratio of the Debt(current US$) in Costa Rica in 2007 to that in 2008?
Provide a short and direct response. 1.53. What is the ratio of the Debt(current US$) in Malaysia in 2007 to that in 2008?
Ensure brevity in your answer.  0.39. What is the ratio of the Debt(current US$) of Mozambique in 2007 to that in 2008?
Give a very brief answer. 1.1. What is the ratio of the Debt(current US$) in Europe(developing only) in 2007 to that in 2009?
Keep it short and to the point. 1.34. What is the ratio of the Debt(current US$) in Costa Rica in 2007 to that in 2009?
Keep it short and to the point. 1.48. What is the ratio of the Debt(current US$) of Malaysia in 2007 to that in 2009?
Your answer should be very brief. 1.23. What is the ratio of the Debt(current US$) in Mozambique in 2007 to that in 2009?
Offer a terse response. 0.94. What is the ratio of the Debt(current US$) in Europe(developing only) in 2007 to that in 2010?
Your answer should be compact. 0.95. What is the ratio of the Debt(current US$) in Costa Rica in 2007 to that in 2010?
Offer a very short reply. 0.14. What is the ratio of the Debt(current US$) of Malaysia in 2007 to that in 2010?
Ensure brevity in your answer.  4.09. What is the ratio of the Debt(current US$) in Mozambique in 2007 to that in 2010?
Your answer should be very brief. 0.21. What is the ratio of the Debt(current US$) in Europe(developing only) in 2008 to that in 2009?
Offer a very short reply. 1.19. What is the ratio of the Debt(current US$) in Costa Rica in 2008 to that in 2009?
Ensure brevity in your answer.  0.97. What is the ratio of the Debt(current US$) in Malaysia in 2008 to that in 2009?
Offer a terse response. 3.12. What is the ratio of the Debt(current US$) in Mozambique in 2008 to that in 2009?
Keep it short and to the point. 0.85. What is the ratio of the Debt(current US$) of Europe(developing only) in 2008 to that in 2010?
Ensure brevity in your answer.  0.85. What is the ratio of the Debt(current US$) in Costa Rica in 2008 to that in 2010?
Make the answer very short. 0.09. What is the ratio of the Debt(current US$) of Malaysia in 2008 to that in 2010?
Your response must be concise. 10.4. What is the ratio of the Debt(current US$) in Mozambique in 2008 to that in 2010?
Your answer should be very brief. 0.19. What is the ratio of the Debt(current US$) of Europe(developing only) in 2009 to that in 2010?
Your answer should be very brief. 0.71. What is the ratio of the Debt(current US$) in Costa Rica in 2009 to that in 2010?
Offer a very short reply. 0.1. What is the ratio of the Debt(current US$) of Malaysia in 2009 to that in 2010?
Make the answer very short. 3.33. What is the ratio of the Debt(current US$) of Mozambique in 2009 to that in 2010?
Your answer should be very brief. 0.23. What is the difference between the highest and the second highest Debt(current US$) in Europe(developing only)?
Your answer should be compact. 3.82e+08. What is the difference between the highest and the second highest Debt(current US$) in Costa Rica?
Provide a short and direct response. 2.18e+08. What is the difference between the highest and the second highest Debt(current US$) in Malaysia?
Make the answer very short. 4.14e+08. What is the difference between the highest and the second highest Debt(current US$) in Mozambique?
Give a very brief answer. 1.84e+08. What is the difference between the highest and the lowest Debt(current US$) in Europe(developing only)?
Your answer should be very brief. 3.07e+09. What is the difference between the highest and the lowest Debt(current US$) of Costa Rica?
Provide a short and direct response. 2.50e+08. What is the difference between the highest and the lowest Debt(current US$) in Malaysia?
Make the answer very short. 1.72e+09. What is the difference between the highest and the lowest Debt(current US$) of Mozambique?
Give a very brief answer. 2.38e+08. 